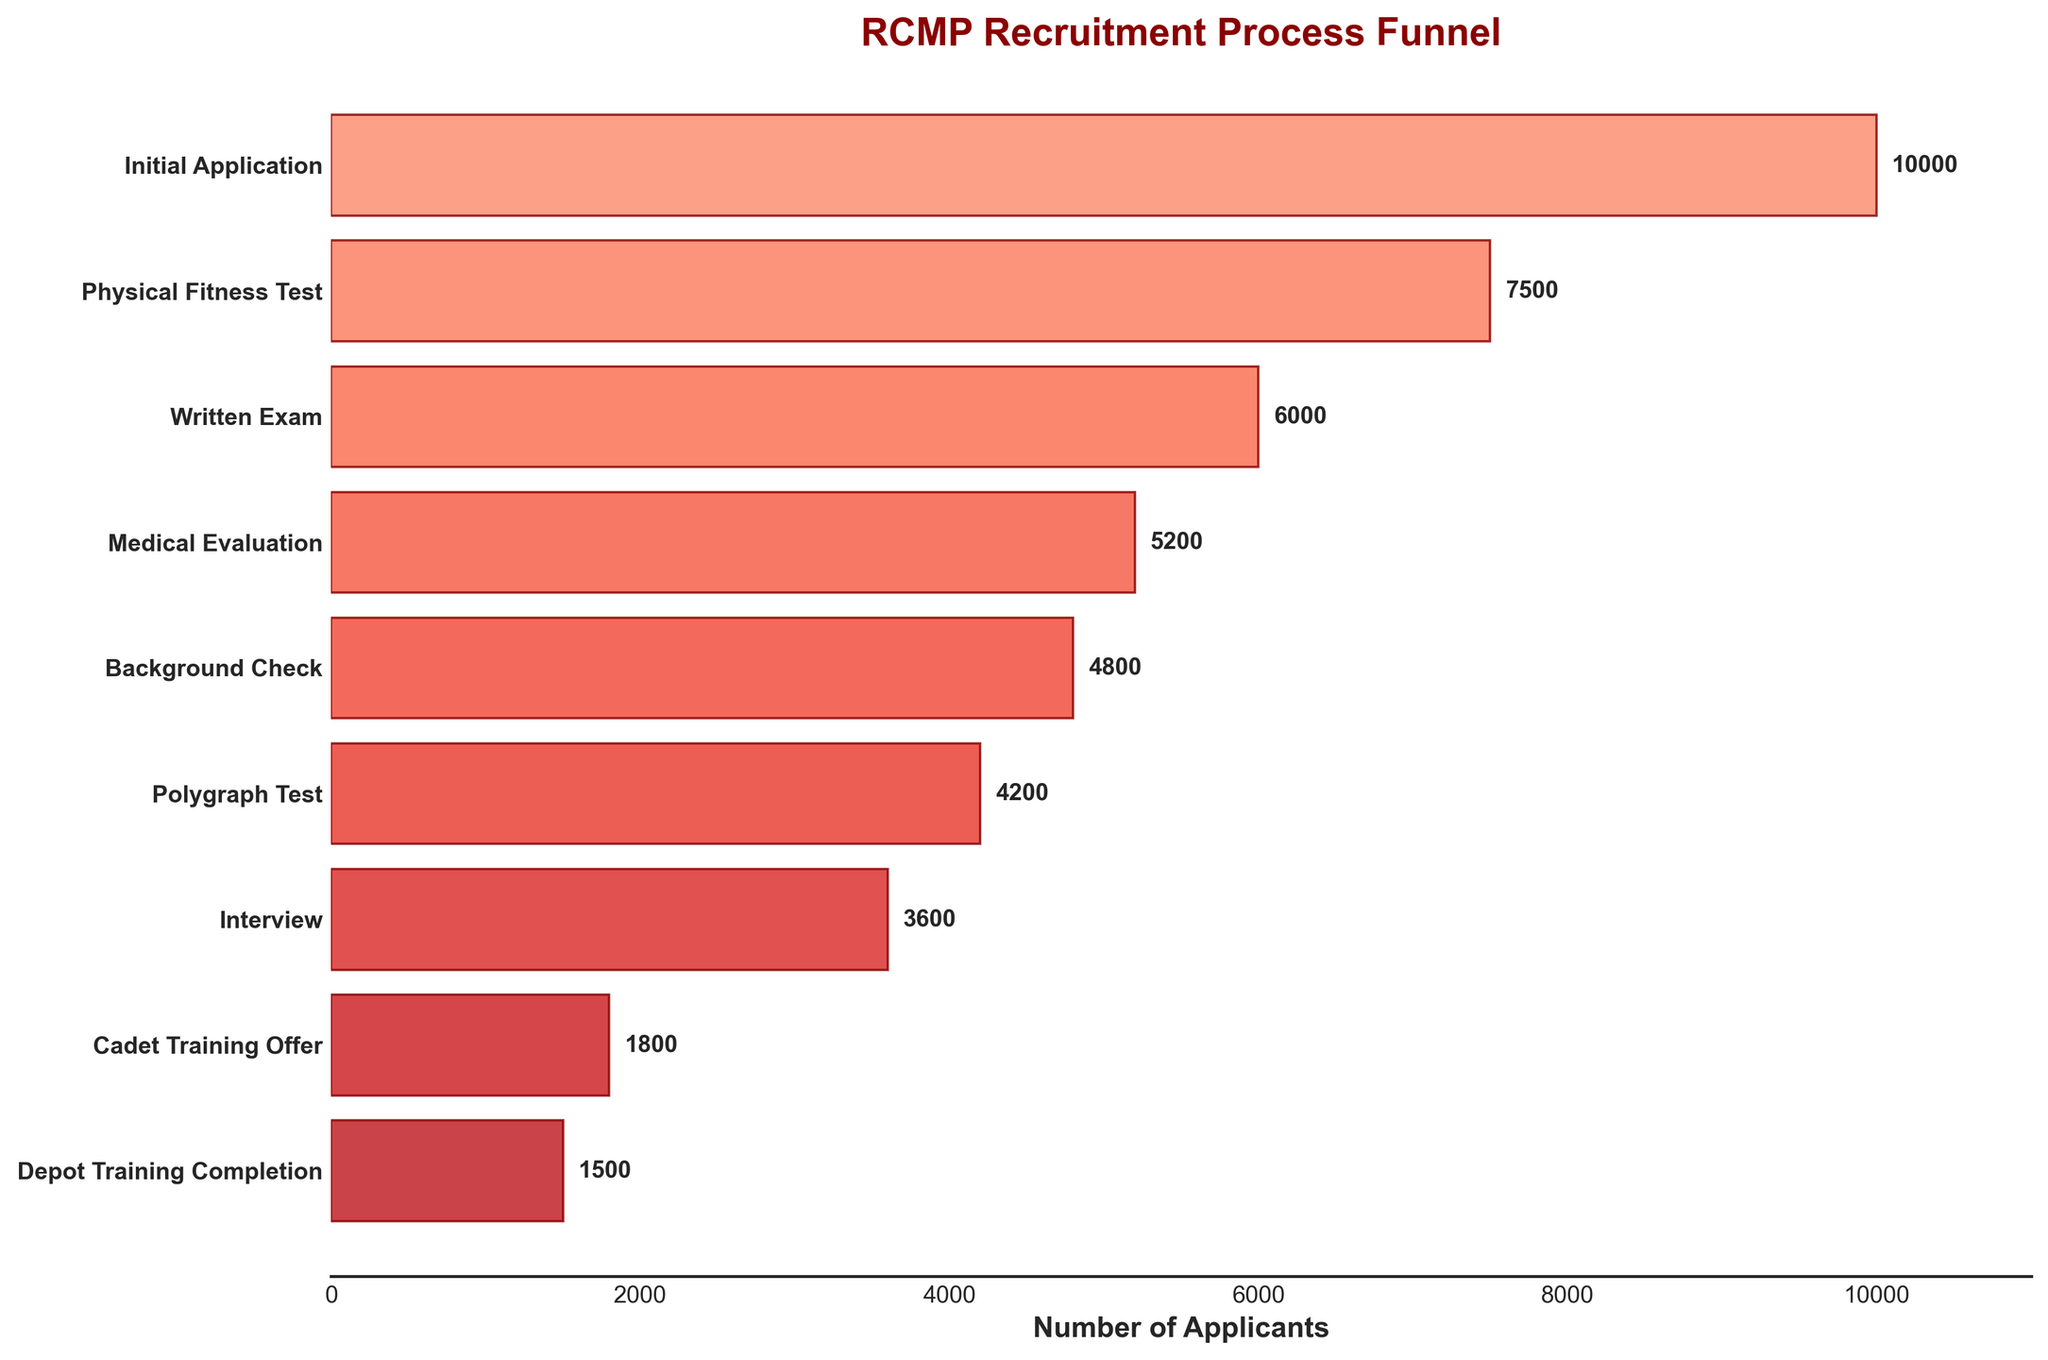What is the title of the figure? The title is the most prominent text at the top of the figure.
Answer: RCMP Recruitment Process Funnel What is the number of applicants at the 'Written Exam' stage? Look at the horizontal bar labeled 'Written Exam' and read the number next to it.
Answer: 6000 How many stages are there in the RCMP recruitment process? Count the number of distinct stages listed on the y-axis.
Answer: 9 Which stage has the largest number of applicants? Compare the length of the horizontal bars and identify the longest bar.
Answer: Initial Application What is the difference in the number of applicants between the 'Initial Application' and 'Cadet Training Offer' stages? Subtract the number of applicants at the 'Cadet Training Offer' stage from the number at the 'Initial Application' stage. 10000 - 1800 = 8200
Answer: 8200 Which stage has the smallest number of applicants? Compare the length of the horizontal bars and identify the shortest bar.
Answer: Depot Training Completion What percentage of applicants pass the 'Physical Fitness Test' relative to the 'Initial Application'? Divide the number of applicants at the 'Physical Fitness Test' stage by the number at the 'Initial Application' stage and multiply by 100. (7500 / 10000) * 100 = 75%
Answer: 75% What is the difference in the number of applicants between the 'Medical Evaluation' and 'Polygraph Test' stages? Subtract the number of applicants at the 'Polygraph Test' stage from the number at the 'Medical Evaluation' stage. 5200 - 4200 = 1000
Answer: 1000 What proportion of applicants who reach the 'Interview' stage successfully complete 'Depot Training'? Divide the number of applicants at the 'Depot Training Completion' stage by the number at the 'Interview' stage. 1500 / 3600 ≈ 0.4167
Answer: 0.4167 Which stage shows the smallest drop in the number of applicants from the previous stage? Calculate the differences between each consecutive stages' number of applicants and identify the smallest difference. 7500 - 6000 = 1500, 6000 - 5200 = 800, 5200 - 4800 = 400, 4800 - 4200 = 600, 4200 - 3600 = 600, 3600 - 1800 = 1800, 1800 - 1500 = 300. Hence, smallest difference is (5200 - 4800) = 400.
Answer: Background Check to Medical Evaluation 